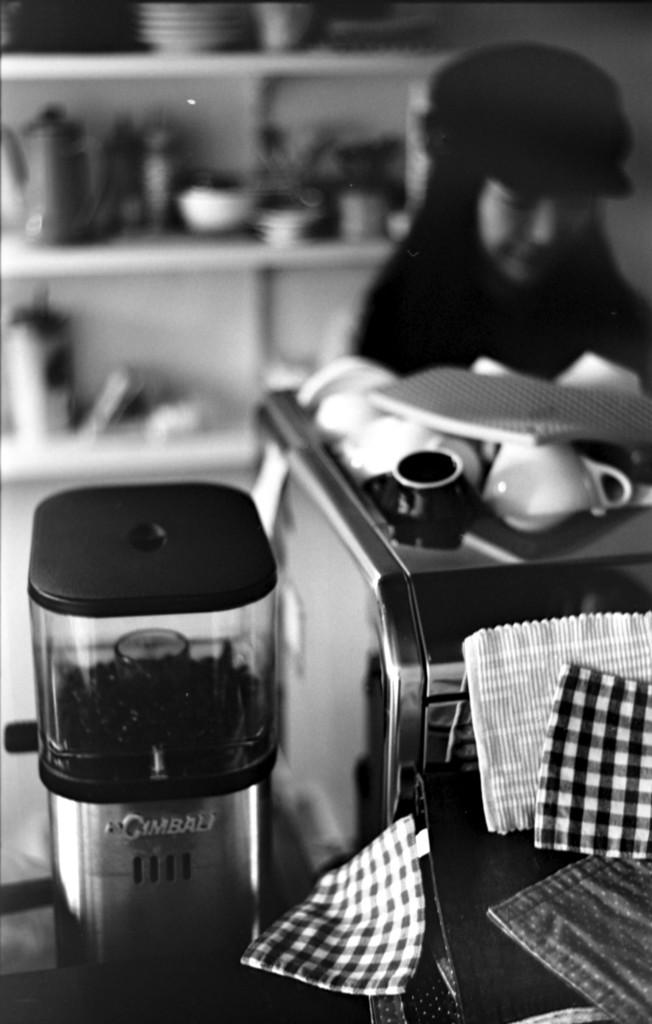<image>
Present a compact description of the photo's key features. An appliance on a counter has a label beginning with G. 